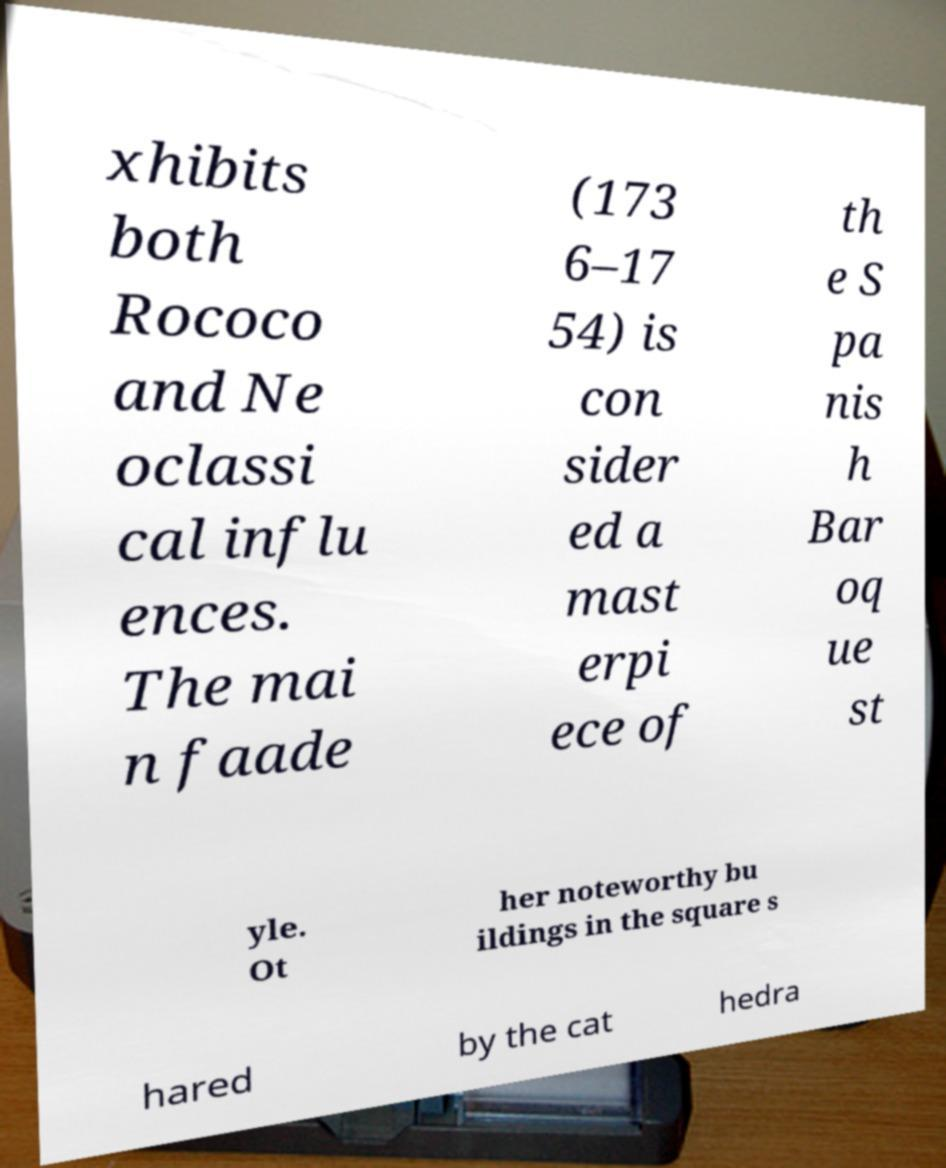Can you accurately transcribe the text from the provided image for me? xhibits both Rococo and Ne oclassi cal influ ences. The mai n faade (173 6–17 54) is con sider ed a mast erpi ece of th e S pa nis h Bar oq ue st yle. Ot her noteworthy bu ildings in the square s hared by the cat hedra 